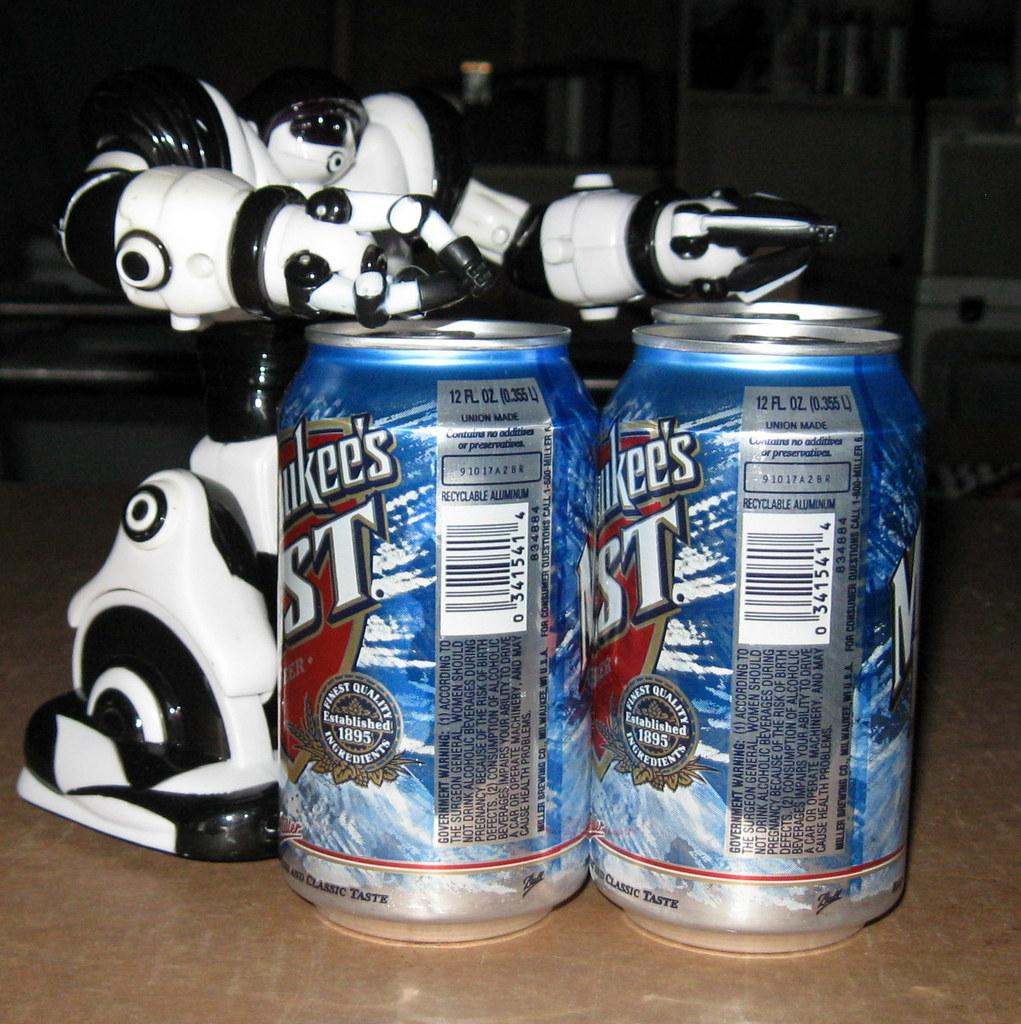<image>
Write a terse but informative summary of the picture. Two cans of drink,  each one saying that it is 12 fluid ounces. 